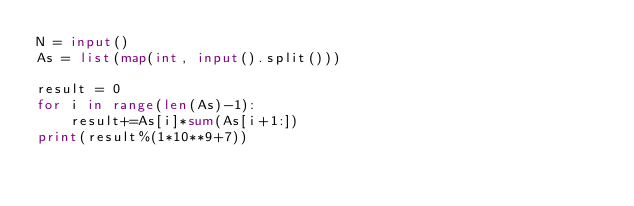Convert code to text. <code><loc_0><loc_0><loc_500><loc_500><_Python_>N = input()
As = list(map(int, input().split()))

result = 0
for i in range(len(As)-1):
    result+=As[i]*sum(As[i+1:])
print(result%(1*10**9+7))
</code> 